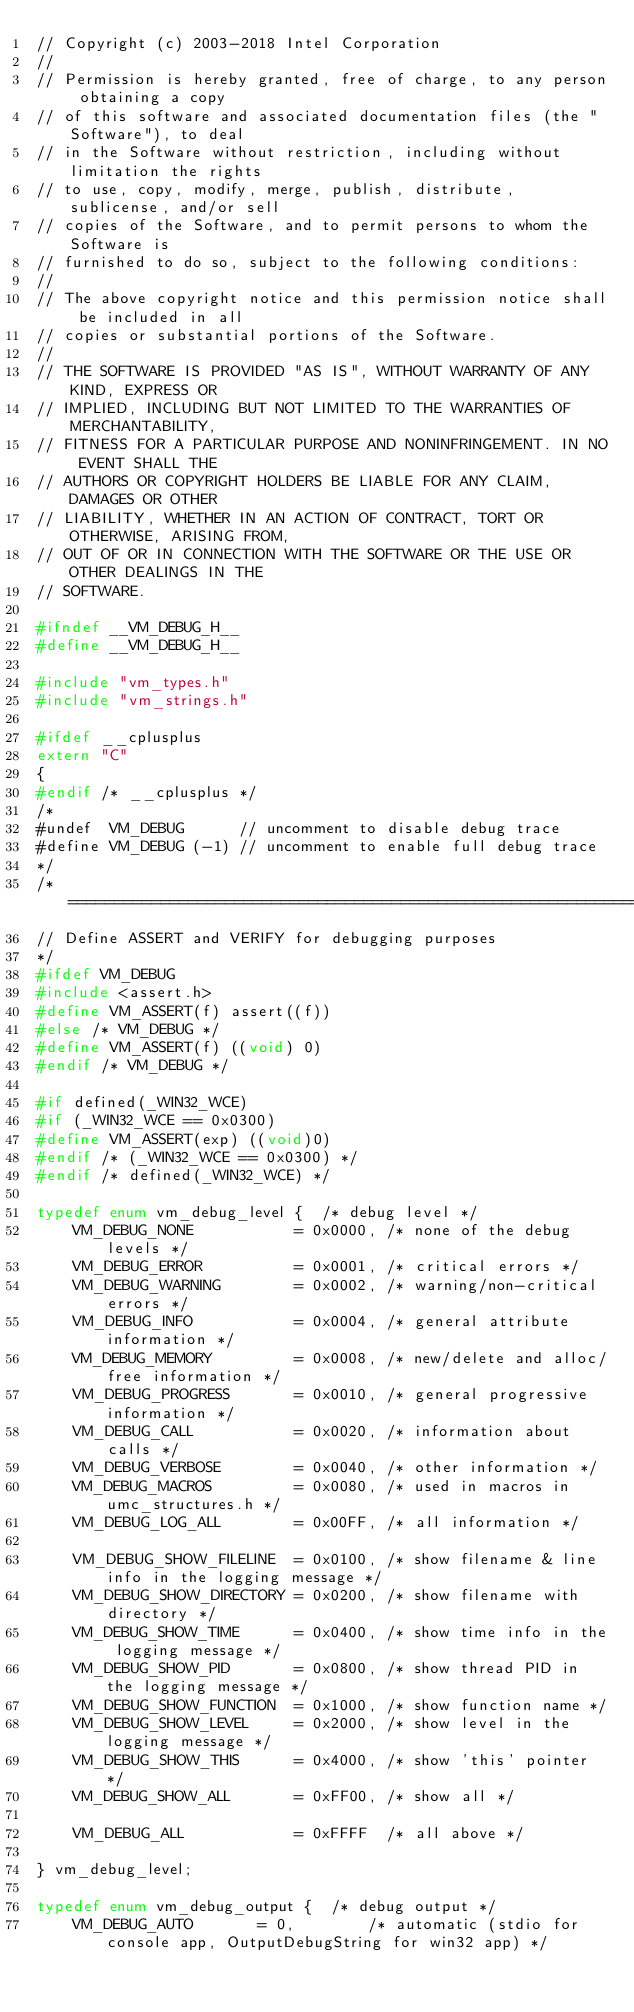Convert code to text. <code><loc_0><loc_0><loc_500><loc_500><_C_>// Copyright (c) 2003-2018 Intel Corporation
//
// Permission is hereby granted, free of charge, to any person obtaining a copy
// of this software and associated documentation files (the "Software"), to deal
// in the Software without restriction, including without limitation the rights
// to use, copy, modify, merge, publish, distribute, sublicense, and/or sell
// copies of the Software, and to permit persons to whom the Software is
// furnished to do so, subject to the following conditions:
//
// The above copyright notice and this permission notice shall be included in all
// copies or substantial portions of the Software.
//
// THE SOFTWARE IS PROVIDED "AS IS", WITHOUT WARRANTY OF ANY KIND, EXPRESS OR
// IMPLIED, INCLUDING BUT NOT LIMITED TO THE WARRANTIES OF MERCHANTABILITY,
// FITNESS FOR A PARTICULAR PURPOSE AND NONINFRINGEMENT. IN NO EVENT SHALL THE
// AUTHORS OR COPYRIGHT HOLDERS BE LIABLE FOR ANY CLAIM, DAMAGES OR OTHER
// LIABILITY, WHETHER IN AN ACTION OF CONTRACT, TORT OR OTHERWISE, ARISING FROM,
// OUT OF OR IN CONNECTION WITH THE SOFTWARE OR THE USE OR OTHER DEALINGS IN THE
// SOFTWARE.

#ifndef __VM_DEBUG_H__
#define __VM_DEBUG_H__

#include "vm_types.h"
#include "vm_strings.h"

#ifdef __cplusplus
extern "C"
{
#endif /* __cplusplus */
/*
#undef  VM_DEBUG      // uncomment to disable debug trace
#define VM_DEBUG (-1) // uncomment to enable full debug trace
*/
/* ============================================================================
// Define ASSERT and VERIFY for debugging purposes
*/
#ifdef VM_DEBUG
#include <assert.h>
#define VM_ASSERT(f) assert((f))
#else /* VM_DEBUG */
#define VM_ASSERT(f) ((void) 0)
#endif /* VM_DEBUG */

#if defined(_WIN32_WCE)
#if (_WIN32_WCE == 0x0300)
#define VM_ASSERT(exp) ((void)0)
#endif /* (_WIN32_WCE == 0x0300) */
#endif /* defined(_WIN32_WCE) */

typedef enum vm_debug_level {  /* debug level */
    VM_DEBUG_NONE           = 0x0000, /* none of the debug levels */
    VM_DEBUG_ERROR          = 0x0001, /* critical errors */
    VM_DEBUG_WARNING        = 0x0002, /* warning/non-critical errors */
    VM_DEBUG_INFO           = 0x0004, /* general attribute information */
    VM_DEBUG_MEMORY         = 0x0008, /* new/delete and alloc/free information */
    VM_DEBUG_PROGRESS       = 0x0010, /* general progressive information */
    VM_DEBUG_CALL           = 0x0020, /* information about calls */
    VM_DEBUG_VERBOSE        = 0x0040, /* other information */
    VM_DEBUG_MACROS         = 0x0080, /* used in macros in umc_structures.h */
    VM_DEBUG_LOG_ALL        = 0x00FF, /* all information */

    VM_DEBUG_SHOW_FILELINE  = 0x0100, /* show filename & line info in the logging message */
    VM_DEBUG_SHOW_DIRECTORY = 0x0200, /* show filename with directory */
    VM_DEBUG_SHOW_TIME      = 0x0400, /* show time info in the logging message */
    VM_DEBUG_SHOW_PID       = 0x0800, /* show thread PID in the logging message */
    VM_DEBUG_SHOW_FUNCTION  = 0x1000, /* show function name */
    VM_DEBUG_SHOW_LEVEL     = 0x2000, /* show level in the logging message */
    VM_DEBUG_SHOW_THIS      = 0x4000, /* show 'this' pointer */
    VM_DEBUG_SHOW_ALL       = 0xFF00, /* show all */

    VM_DEBUG_ALL            = 0xFFFF  /* all above */

} vm_debug_level;

typedef enum vm_debug_output {  /* debug output */
    VM_DEBUG_AUTO       = 0,        /* automatic (stdio for console app, OutputDebugString for win32 app) */</code> 